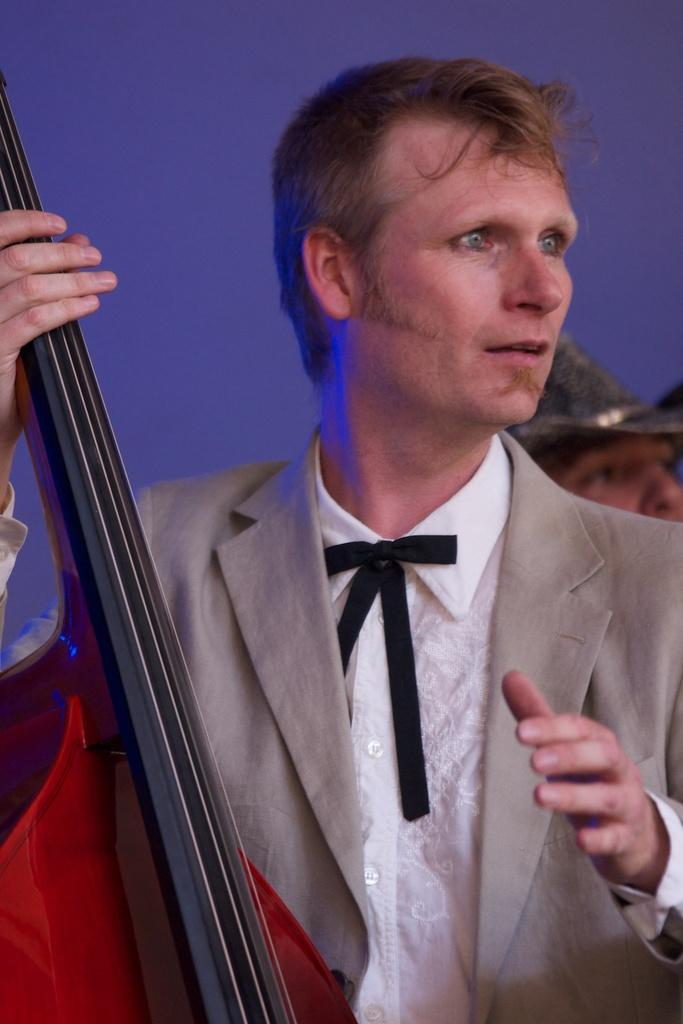What is the person in the image wearing? The person in the image is wearing a suit. What is the person doing while wearing the suit? The person is playing a brass instrument. Can you describe the appearance of the other person in the image? The other person in the image is wearing a hat. What can be observed about the background of the image? The background of the image is blurred. How many lines are visible on the hat of the person in the image? There are no lines mentioned on the hat of the person in the image. The provided facts do not mention any lines or specific details about the hat. 